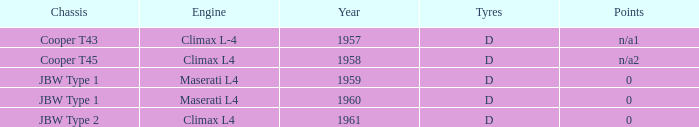What is the engine for a vehicle in 1960? Maserati L4. Can you parse all the data within this table? {'header': ['Chassis', 'Engine', 'Year', 'Tyres', 'Points'], 'rows': [['Cooper T43', 'Climax L-4', '1957', 'D', 'n/a1'], ['Cooper T45', 'Climax L4', '1958', 'D', 'n/a2'], ['JBW Type 1', 'Maserati L4', '1959', 'D', '0'], ['JBW Type 1', 'Maserati L4', '1960', 'D', '0'], ['JBW Type 2', 'Climax L4', '1961', 'D', '0']]} 